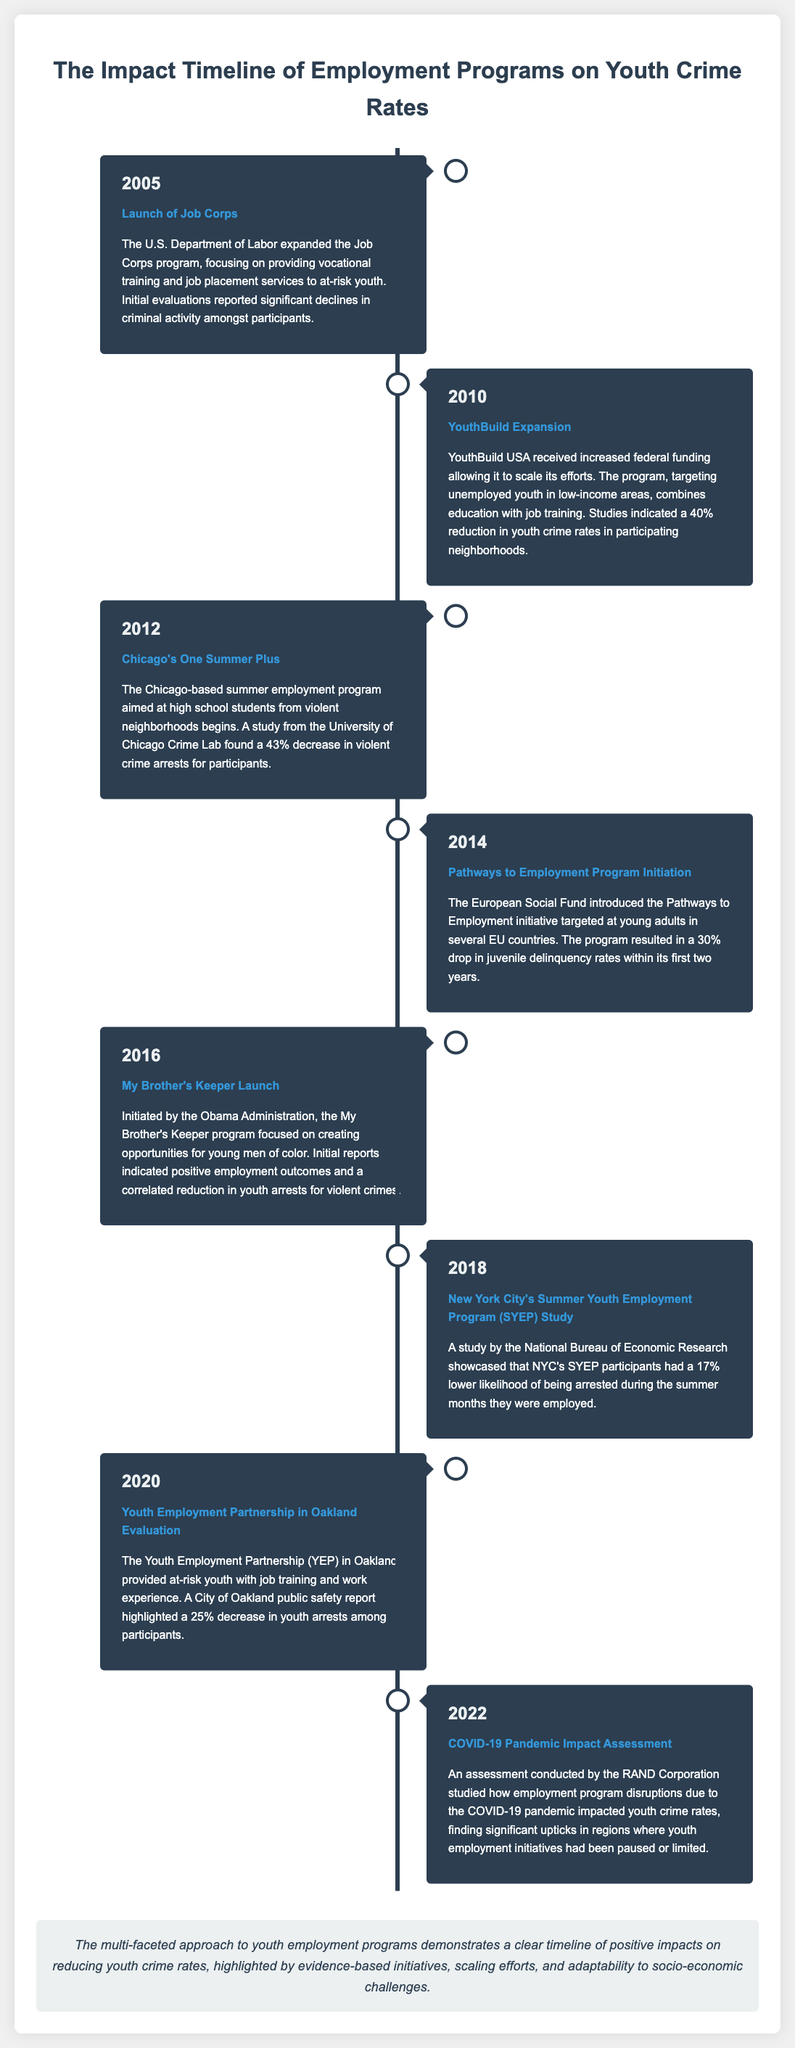What was the year when the Job Corps program was expanded? The timeline shows that the Job Corps program was expanded in 2005.
Answer: 2005 What percentage reduction in youth crime rates was observed in neighborhoods participating in YouthBuild? According to the document, a 40% reduction in youth crime rates was reported in neighborhoods participating in YouthBuild.
Answer: 40% Which program initiated in 2016 aimed at creating opportunities for young men of color? The document identifies the My Brother's Keeper program, launched in 2016, as focusing on creating opportunities for young men of color.
Answer: My Brother's Keeper What was the percentage drop in juvenile delinquency rates attributed to the Pathways to Employment initiative in its first two years? The document states that the Pathways to Employment initiative resulted in a 30% drop in juvenile delinquency rates within its first two years.
Answer: 30% Which organization conducted an assessment of the impact of the COVID-19 pandemic on youth employment programs? The RAND Corporation is mentioned as the organization that conducted the assessment regarding the impact of the COVID-19 pandemic.
Answer: RAND Corporation Which year showed an assessment of the effect of a summer employment program in Chicago? The timeline indicates that the assessment of the summer employment program in Chicago was conducted in 2012.
Answer: 2012 How much lower was the likelihood of participants in NYC's SYEP being arrested during the summer months? The study reported a 17% lower likelihood of arrest for participants in NYC's SYEP during the summer months they were employed.
Answer: 17% What was the conclusion about youth employment programs' impact on crime rates according to the timeline? The conclusion highlights that youth employment programs have a positive impact on reducing youth crime rates.
Answer: Positive impact 